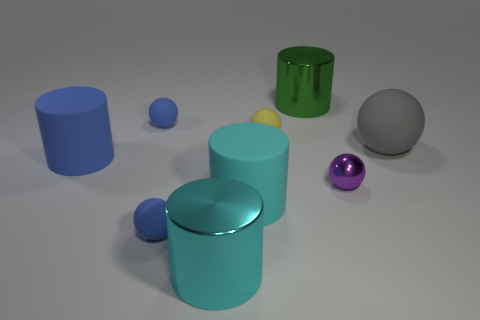Subtract all purple balls. How many balls are left? 4 Subtract all tiny purple metal spheres. How many spheres are left? 4 Subtract all red spheres. Subtract all blue cylinders. How many spheres are left? 5 Add 1 small yellow objects. How many objects exist? 10 Subtract all spheres. How many objects are left? 4 Subtract 0 cyan spheres. How many objects are left? 9 Subtract all large cylinders. Subtract all gray rubber cylinders. How many objects are left? 5 Add 5 cyan rubber things. How many cyan rubber things are left? 6 Add 8 small yellow rubber spheres. How many small yellow rubber spheres exist? 9 